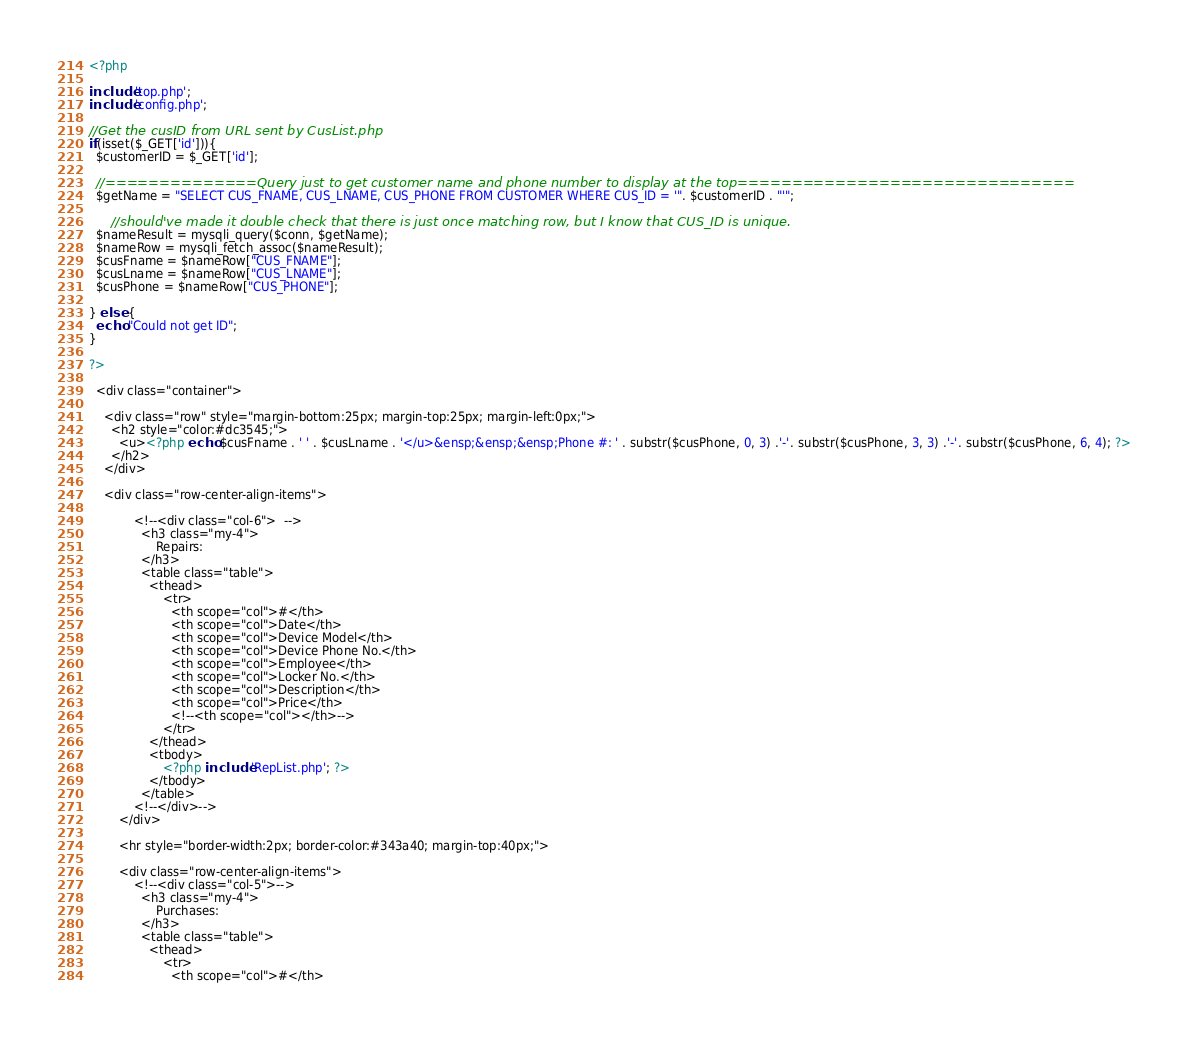Convert code to text. <code><loc_0><loc_0><loc_500><loc_500><_PHP_><?php

include 'top.php';
include 'config.php';

//Get the cusID from URL sent by CusList.php
if(isset($_GET['id'])){
  $customerID = $_GET['id'];
  
  //==============Query just to get customer name and phone number to display at the top===============================
  $getName = "SELECT CUS_FNAME, CUS_LNAME, CUS_PHONE FROM CUSTOMER WHERE CUS_ID = '". $customerID . "'";
  
      //should've made it double check that there is just once matching row, but I know that CUS_ID is unique.
  $nameResult = mysqli_query($conn, $getName);
  $nameRow = mysqli_fetch_assoc($nameResult);
  $cusFname = $nameRow["CUS_FNAME"];
  $cusLname = $nameRow["CUS_LNAME"];
  $cusPhone = $nameRow["CUS_PHONE"];
  
} else {
  echo "Could not get ID";
}

?>

  <div class="container">

    <div class="row" style="margin-bottom:25px; margin-top:25px; margin-left:0px;">
      <h2 style="color:#dc3545;">
        <u><?php echo $cusFname . ' ' . $cusLname . '</u>&ensp;&ensp;&ensp;Phone #: ' . substr($cusPhone, 0, 3) .'-'. substr($cusPhone, 3, 3) .'-'. substr($cusPhone, 6, 4); ?>
      </h2>
    </div>

    <div class="row-center-align-items">
        
            <!--<div class="col-6">  -->
              <h3 class="my-4">
                  Repairs: 
              </h3>
              <table class="table">
                <thead>
                    <tr>
                      <th scope="col">#</th>
                      <th scope="col">Date</th>
                      <th scope="col">Device Model</th>
                      <th scope="col">Device Phone No.</th>
                      <th scope="col">Employee</th>
                      <th scope="col">Locker No.</th>
                      <th scope="col">Description</th>
                      <th scope="col">Price</th>
                      <!--<th scope="col"></th>-->
                    </tr>
                </thead>
                <tbody>
                    <?php include 'RepList.php'; ?>
                </tbody>
              </table>
            <!--</div>-->
        </div>
        
        <hr style="border-width:2px; border-color:#343a40; margin-top:40px;">

        <div class="row-center-align-items">
            <!--<div class="col-5">-->
              <h3 class="my-4">
                  Purchases: 
              </h3>
              <table class="table">
                <thead>
                    <tr>
                      <th scope="col">#</th></code> 